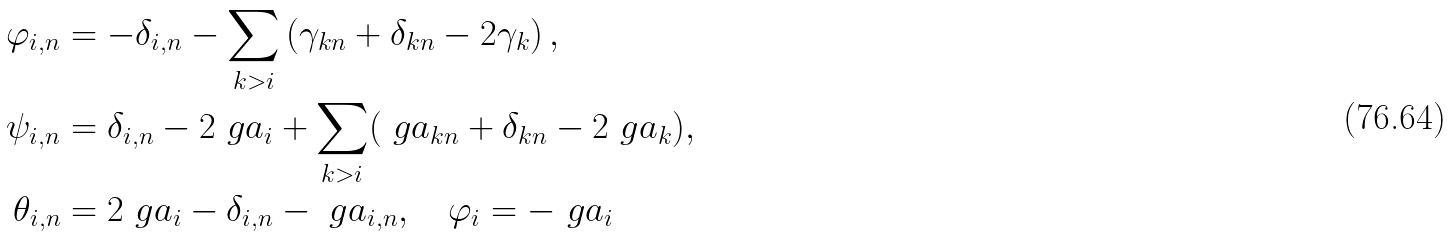Convert formula to latex. <formula><loc_0><loc_0><loc_500><loc_500>\varphi _ { i , n } & = - \delta _ { i , n } - \sum _ { k > i } \left ( \gamma _ { k n } + \delta _ { k n } - 2 \gamma _ { k } \right ) , \\ \psi _ { i , n } & = \delta _ { i , n } - 2 \ g a _ { i } + \sum _ { k > i } ( \ g a _ { k n } + \delta _ { k n } - 2 \ g a _ { k } ) , \\ \theta _ { i , n } & = 2 \ g a _ { i } - \delta _ { i , n } - \ g a _ { i , n } , \quad \varphi _ { i } = - \ g a _ { i }</formula> 